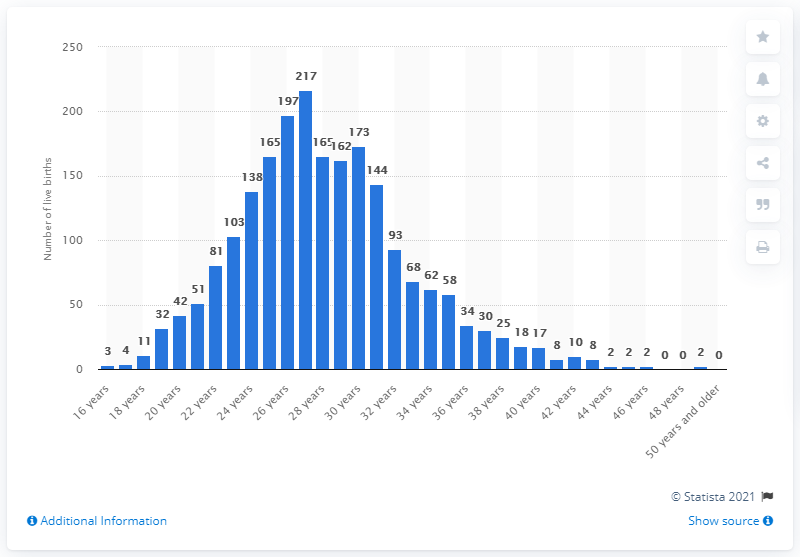Draw attention to some important aspects in this diagram. In Iceland in 2020, approximately 51 women who were 40 years or older gave birth to their first baby. 